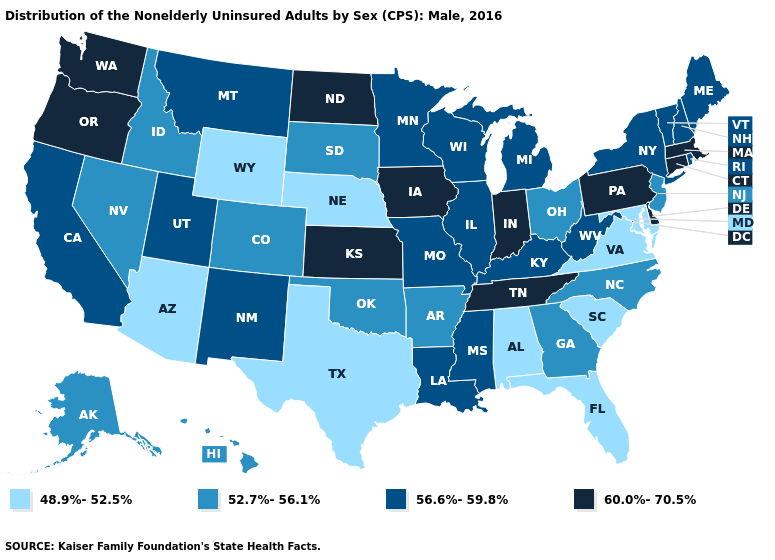Which states hav the highest value in the Northeast?
Give a very brief answer. Connecticut, Massachusetts, Pennsylvania. Does the first symbol in the legend represent the smallest category?
Be succinct. Yes. What is the highest value in the USA?
Quick response, please. 60.0%-70.5%. Does Kentucky have the highest value in the USA?
Give a very brief answer. No. What is the value of New Hampshire?
Answer briefly. 56.6%-59.8%. Does Nevada have the highest value in the USA?
Quick response, please. No. Does the map have missing data?
Answer briefly. No. Name the states that have a value in the range 52.7%-56.1%?
Give a very brief answer. Alaska, Arkansas, Colorado, Georgia, Hawaii, Idaho, Nevada, New Jersey, North Carolina, Ohio, Oklahoma, South Dakota. Does Arizona have the lowest value in the West?
Keep it brief. Yes. What is the value of Delaware?
Short answer required. 60.0%-70.5%. Which states have the lowest value in the USA?
Concise answer only. Alabama, Arizona, Florida, Maryland, Nebraska, South Carolina, Texas, Virginia, Wyoming. Which states have the lowest value in the South?
Short answer required. Alabama, Florida, Maryland, South Carolina, Texas, Virginia. Among the states that border Wyoming , does Montana have the highest value?
Give a very brief answer. Yes. Does North Carolina have a lower value than California?
Concise answer only. Yes. Name the states that have a value in the range 48.9%-52.5%?
Keep it brief. Alabama, Arizona, Florida, Maryland, Nebraska, South Carolina, Texas, Virginia, Wyoming. 